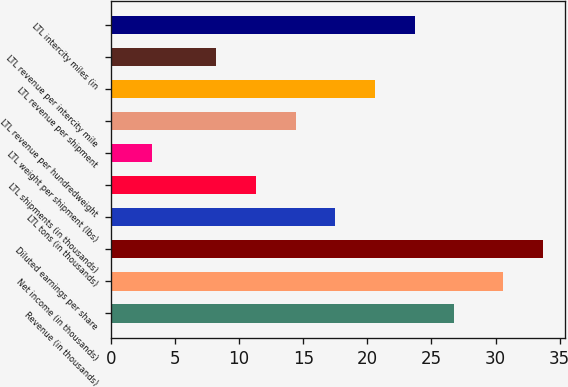Convert chart to OTSL. <chart><loc_0><loc_0><loc_500><loc_500><bar_chart><fcel>Revenue (in thousands)<fcel>Net income (in thousands)<fcel>Diluted earnings per share<fcel>LTL tons (in thousands)<fcel>LTL shipments (in thousands)<fcel>LTL weight per shipment (lbs)<fcel>LTL revenue per hundredweight<fcel>LTL revenue per shipment<fcel>LTL revenue per intercity mile<fcel>LTL intercity miles (in<nl><fcel>26.8<fcel>30.6<fcel>33.7<fcel>17.5<fcel>11.3<fcel>3.2<fcel>14.4<fcel>20.6<fcel>8.2<fcel>23.7<nl></chart> 